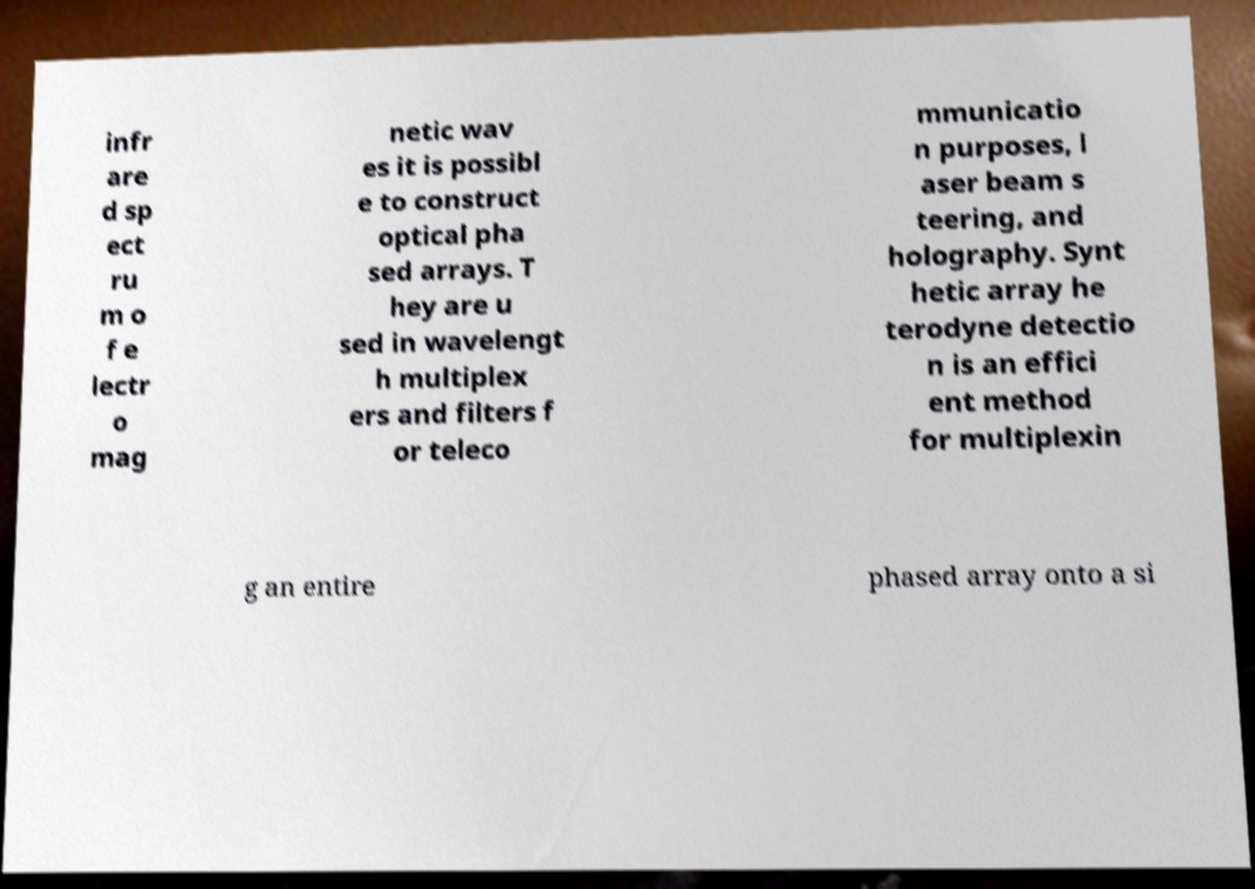Could you extract and type out the text from this image? infr are d sp ect ru m o f e lectr o mag netic wav es it is possibl e to construct optical pha sed arrays. T hey are u sed in wavelengt h multiplex ers and filters f or teleco mmunicatio n purposes, l aser beam s teering, and holography. Synt hetic array he terodyne detectio n is an effici ent method for multiplexin g an entire phased array onto a si 